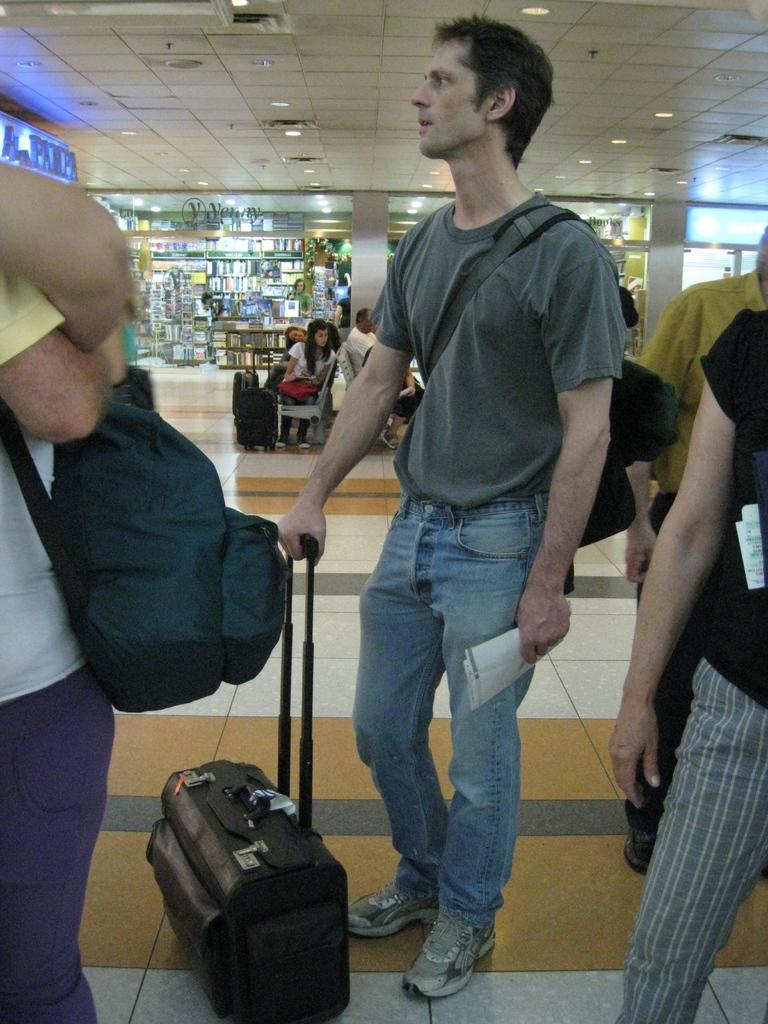What can be seen in the image? There are people in the image, some of whom are holding bags and luggage. What is visible in the background? There are stalls and glass doors in the background. Can you describe the left side of the image? There is a banner and a light roof on the left side of the image. Is there a guide holding a bear in the image? No, there is no guide or bear present in the image. Can you see a scarecrow in the image? No, there is no scarecrow present in the image. 